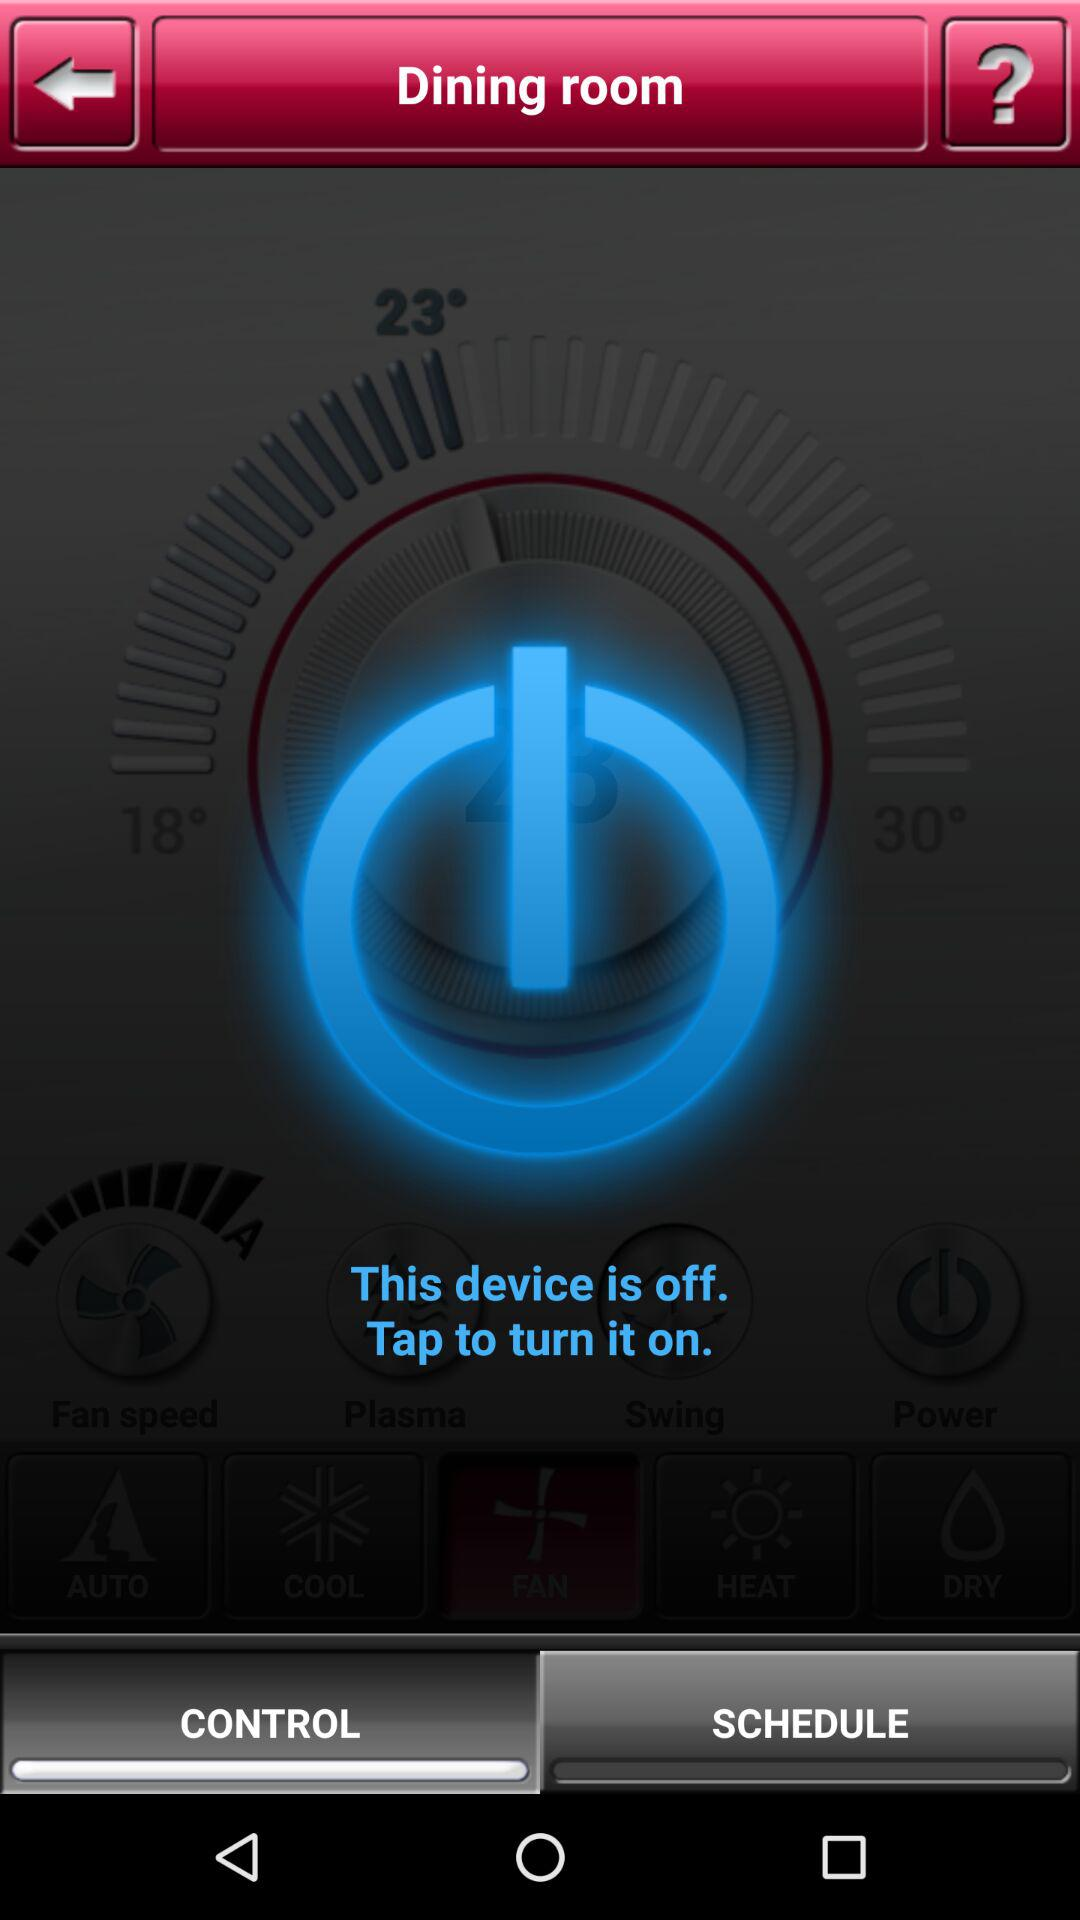What is the status of "This device"? The status is "off". 